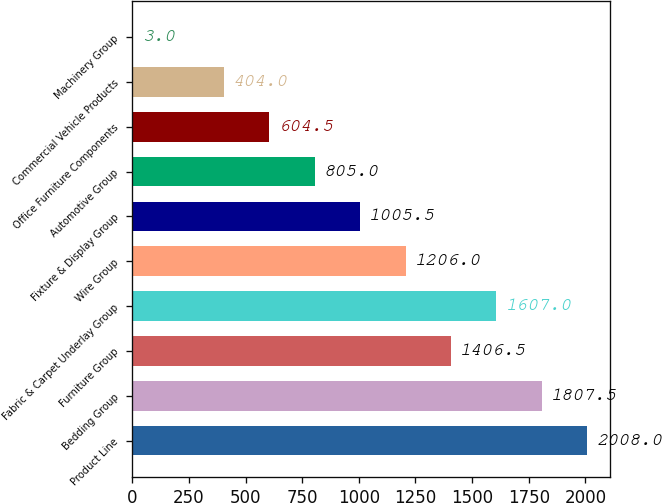<chart> <loc_0><loc_0><loc_500><loc_500><bar_chart><fcel>Product Line<fcel>Bedding Group<fcel>Furniture Group<fcel>Fabric & Carpet Underlay Group<fcel>Wire Group<fcel>Fixture & Display Group<fcel>Automotive Group<fcel>Office Furniture Components<fcel>Commercial Vehicle Products<fcel>Machinery Group<nl><fcel>2008<fcel>1807.5<fcel>1406.5<fcel>1607<fcel>1206<fcel>1005.5<fcel>805<fcel>604.5<fcel>404<fcel>3<nl></chart> 